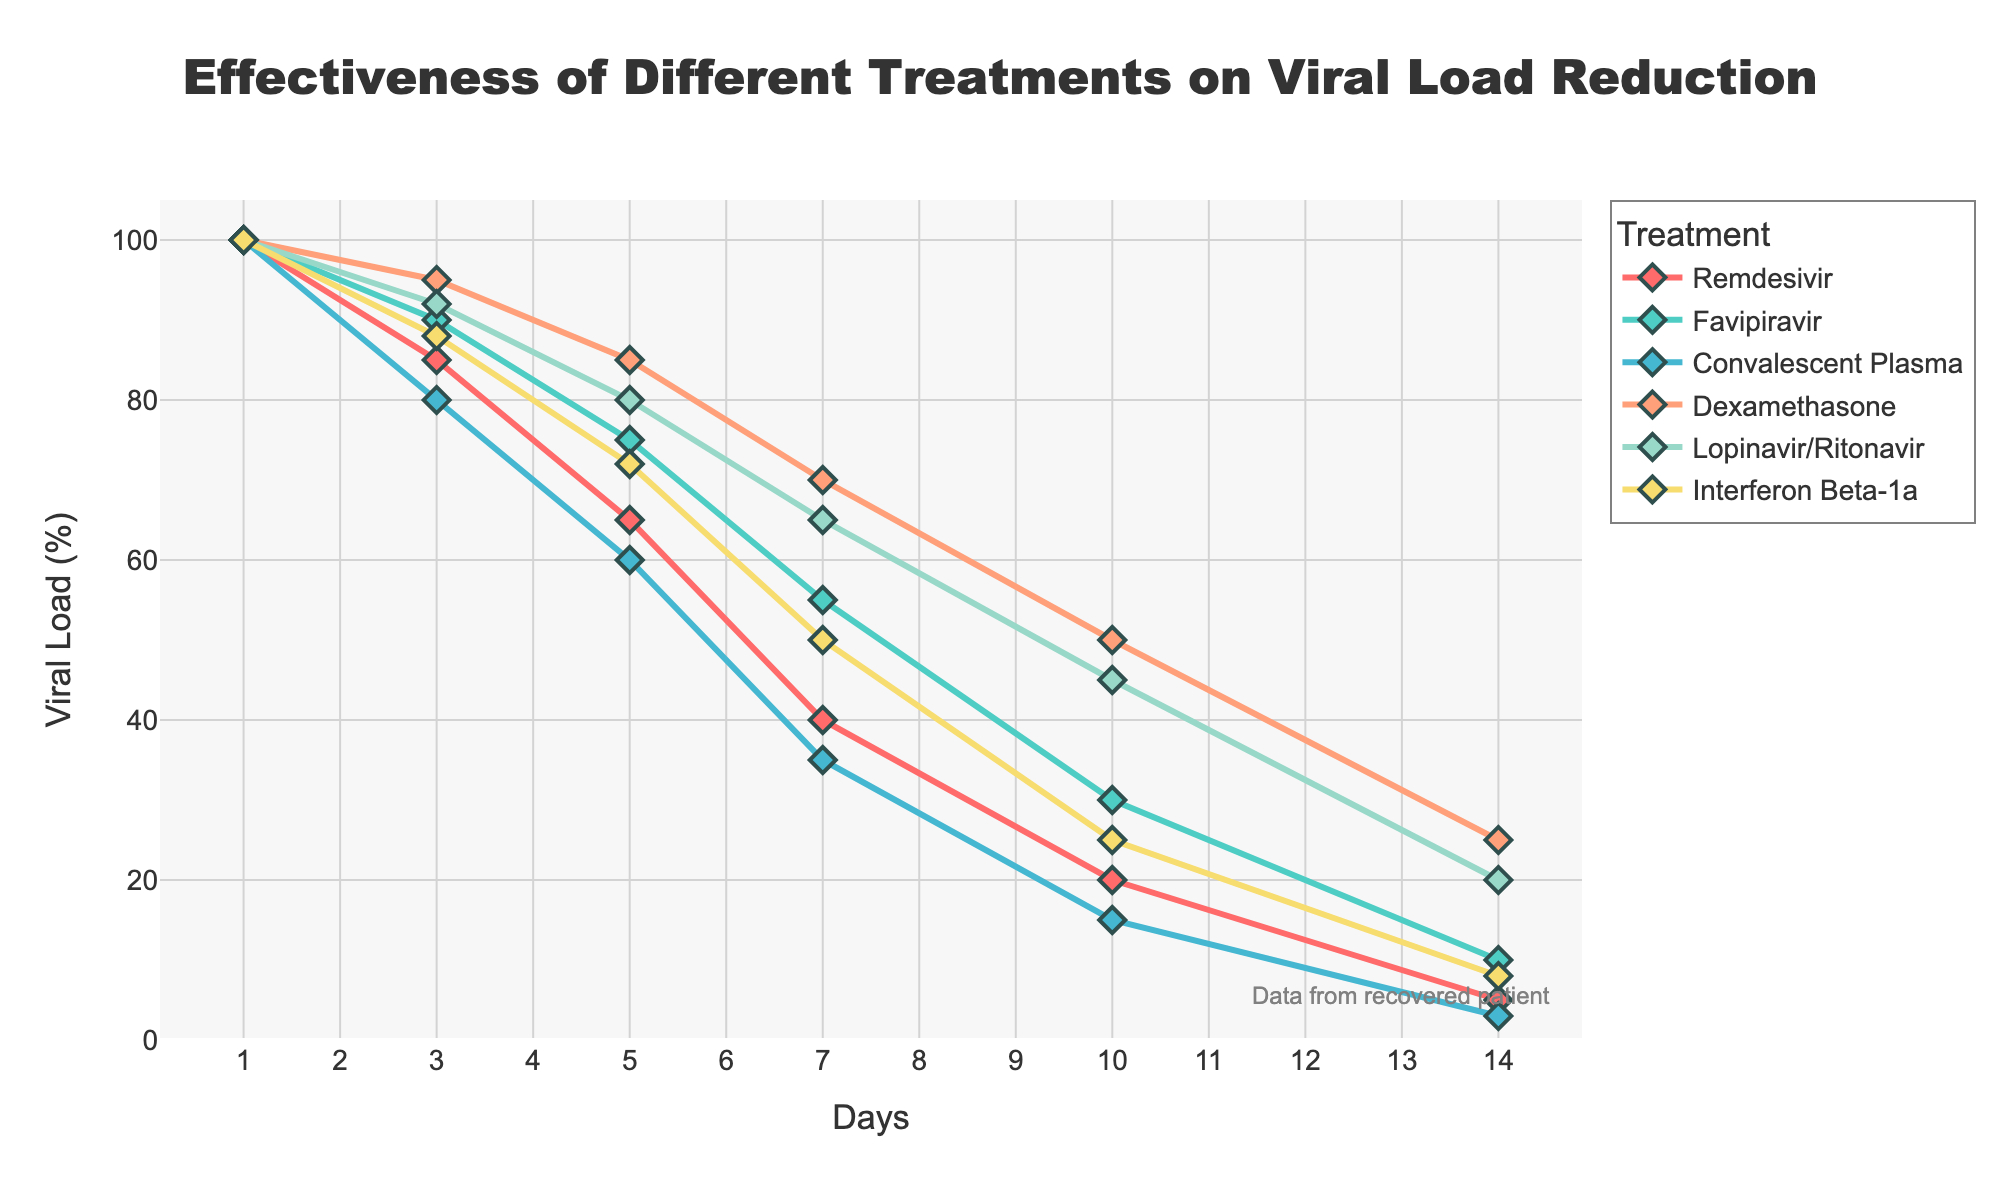What treatment shows the minimum viral load reduction by Day 14? By examining the values at Day 14 for each treatment line, the minimum viral load percentage can be identified. Dexamethasone shows the highest percentage at Day 14, which is 25%, indicating the minimum reduction.
Answer: Dexamethasone Which treatment is the most effective in reducing viral load by Day 3? Review the values for Day 3 across all treatments. The treatment with the lowest viral load is Convalescent Plasma at 80%.
Answer: Convalescent Plasma What is the difference in viral load between Favipiravir and Interferon Beta-1a on Day 7? Locate the viral loads for Favipiravir (55%) and Interferon Beta-1a (50%) on Day 7 and calculate the difference: 55% - 50% = 5%.
Answer: 5% Which treatment demonstrates the most rapid initial reduction between Day 1 and Day 3? Calculate the drop in viral load from Day 1 to Day 3 for each treatment. Remdesivir shows a drop from 100% to 85%, which is a reduction of 15%, the largest initial decrease among all treatments.
Answer: Remdesivir On which day does Remdesivir reach a viral load of 20%? Trace the progression of viral loads for Remdesivir. Remdesivir reaches a viral load of 20% on Day 10.
Answer: Day 10 By how many percentage points does Lopinavir/Ritonavir’s viral load decrease from Day 5 to Day 14? For Lopinavir/Ritonavir, compare the viral loads at Day 5 (80%) and Day 14 (20%). The decrease is 80% - 20% = 60 percentage points.
Answer: 60 Which treatment shows a consistently high viral load reduction throughout all the days? By examining the trend lines, Remdesivir consistently shows high viral load reduction, reaching one of the lowest values (5%) by Day 14.
Answer: Remdesivir What is the average viral load percentage across all treatments on Day 10? Add the viral loads on Day 10 for each treatment (20 + 30 + 15 + 50 + 45 + 25 = 185) and divide by the number of treatments (6), so 185 / 6 ≈ 30.83%.
Answer: 30.83% How does the rate of reduction in viral load for Dexamethasone compare to Favipiravir between Day 3 and Day 5? For Dexamethasone, the viral load drops from 95% to 85% (a 10% decrease), and for Favipiravir, it drops from 90% to 75% (a 15% decrease). Thus, Favipiravir has a higher rate of reduction in this interval.
Answer: Favipiravir What is the proportional change in viral load for Convalescent Plasma from Day 1 to Day 14? The viral load for Convalescent Plasma goes from 100% at Day 1 to 3% at Day 14. The proportional change is (100 - 3) / 100 = 0.97 or 97%.
Answer: 97% 